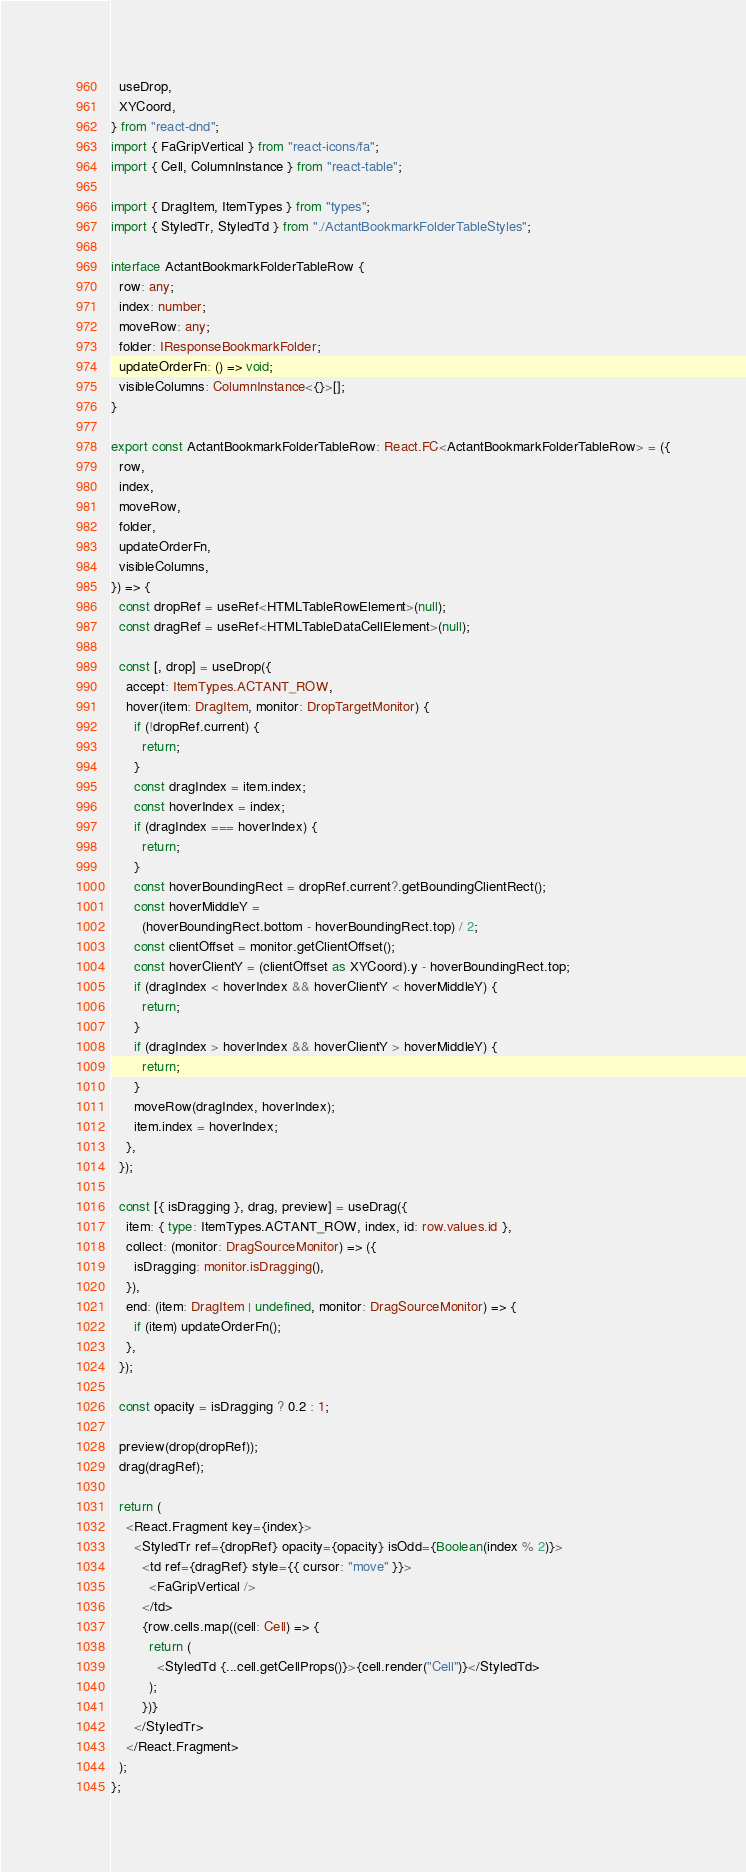<code> <loc_0><loc_0><loc_500><loc_500><_TypeScript_>  useDrop,
  XYCoord,
} from "react-dnd";
import { FaGripVertical } from "react-icons/fa";
import { Cell, ColumnInstance } from "react-table";

import { DragItem, ItemTypes } from "types";
import { StyledTr, StyledTd } from "./ActantBookmarkFolderTableStyles";

interface ActantBookmarkFolderTableRow {
  row: any;
  index: number;
  moveRow: any;
  folder: IResponseBookmarkFolder;
  updateOrderFn: () => void;
  visibleColumns: ColumnInstance<{}>[];
}

export const ActantBookmarkFolderTableRow: React.FC<ActantBookmarkFolderTableRow> = ({
  row,
  index,
  moveRow,
  folder,
  updateOrderFn,
  visibleColumns,
}) => {
  const dropRef = useRef<HTMLTableRowElement>(null);
  const dragRef = useRef<HTMLTableDataCellElement>(null);

  const [, drop] = useDrop({
    accept: ItemTypes.ACTANT_ROW,
    hover(item: DragItem, monitor: DropTargetMonitor) {
      if (!dropRef.current) {
        return;
      }
      const dragIndex = item.index;
      const hoverIndex = index;
      if (dragIndex === hoverIndex) {
        return;
      }
      const hoverBoundingRect = dropRef.current?.getBoundingClientRect();
      const hoverMiddleY =
        (hoverBoundingRect.bottom - hoverBoundingRect.top) / 2;
      const clientOffset = monitor.getClientOffset();
      const hoverClientY = (clientOffset as XYCoord).y - hoverBoundingRect.top;
      if (dragIndex < hoverIndex && hoverClientY < hoverMiddleY) {
        return;
      }
      if (dragIndex > hoverIndex && hoverClientY > hoverMiddleY) {
        return;
      }
      moveRow(dragIndex, hoverIndex);
      item.index = hoverIndex;
    },
  });

  const [{ isDragging }, drag, preview] = useDrag({
    item: { type: ItemTypes.ACTANT_ROW, index, id: row.values.id },
    collect: (monitor: DragSourceMonitor) => ({
      isDragging: monitor.isDragging(),
    }),
    end: (item: DragItem | undefined, monitor: DragSourceMonitor) => {
      if (item) updateOrderFn();
    },
  });

  const opacity = isDragging ? 0.2 : 1;

  preview(drop(dropRef));
  drag(dragRef);

  return (
    <React.Fragment key={index}>
      <StyledTr ref={dropRef} opacity={opacity} isOdd={Boolean(index % 2)}>
        <td ref={dragRef} style={{ cursor: "move" }}>
          <FaGripVertical />
        </td>
        {row.cells.map((cell: Cell) => {
          return (
            <StyledTd {...cell.getCellProps()}>{cell.render("Cell")}</StyledTd>
          );
        })}
      </StyledTr>
    </React.Fragment>
  );
};
</code> 